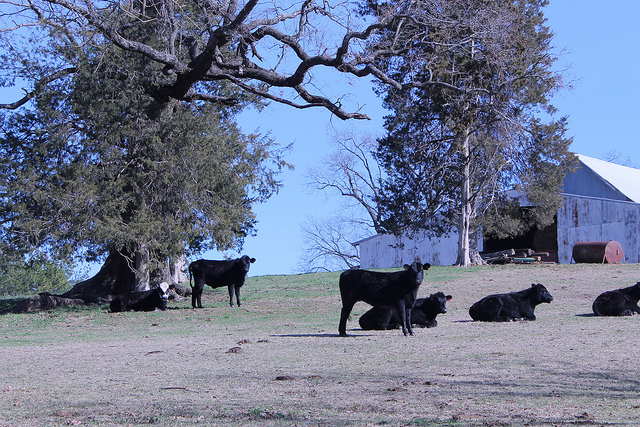<image>Which cow has 2 colors? I don't know which cow has 2 colors. The answers refer to various cows such as the one laying down, one on left, or the cow under the tree. Which cow has 2 colors? I don't know which cow has 2 colors. It could be the one laying down, the one on the left, or the one in the back. 